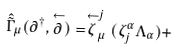Convert formula to latex. <formula><loc_0><loc_0><loc_500><loc_500>\hat { \tilde { \Gamma } } _ { \mu } ( \partial ^ { \dagger } , \stackrel { \leftarrow } { \partial } ) = \stackrel { \leftarrow } { \zeta } ^ { j } _ { \mu } ( \zeta ^ { \alpha } _ { j } \Lambda _ { \alpha } ) +</formula> 